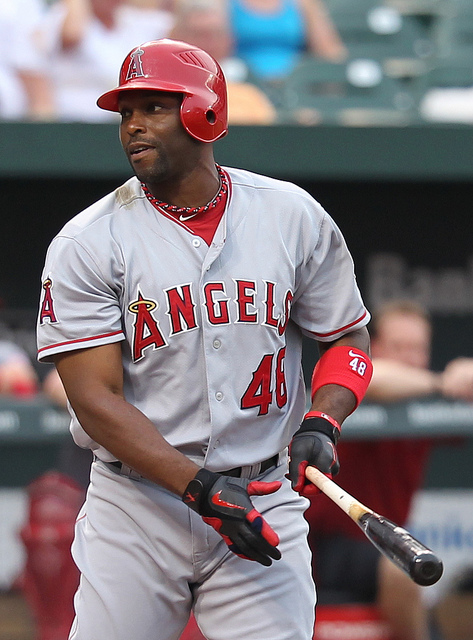Read and extract the text from this image. A ANGELS 46 A 48 